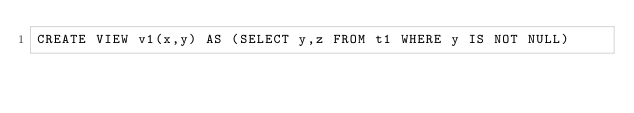<code> <loc_0><loc_0><loc_500><loc_500><_SQL_>CREATE VIEW v1(x,y) AS (SELECT y,z FROM t1 WHERE y IS NOT NULL)</code> 